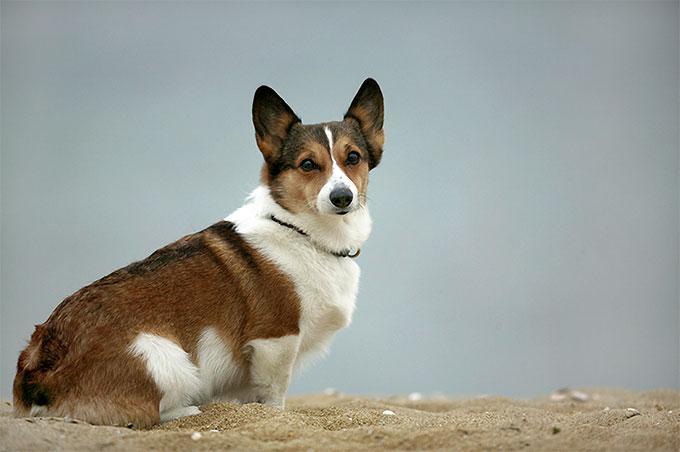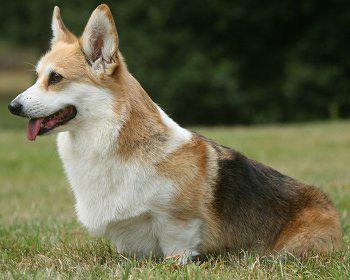The first image is the image on the left, the second image is the image on the right. Evaluate the accuracy of this statement regarding the images: "In one image, the dog is not on green grass.". Is it true? Answer yes or no. Yes. The first image is the image on the left, the second image is the image on the right. For the images displayed, is the sentence "At least one dog has it's head facing toward the left side of the image." factually correct? Answer yes or no. Yes. 